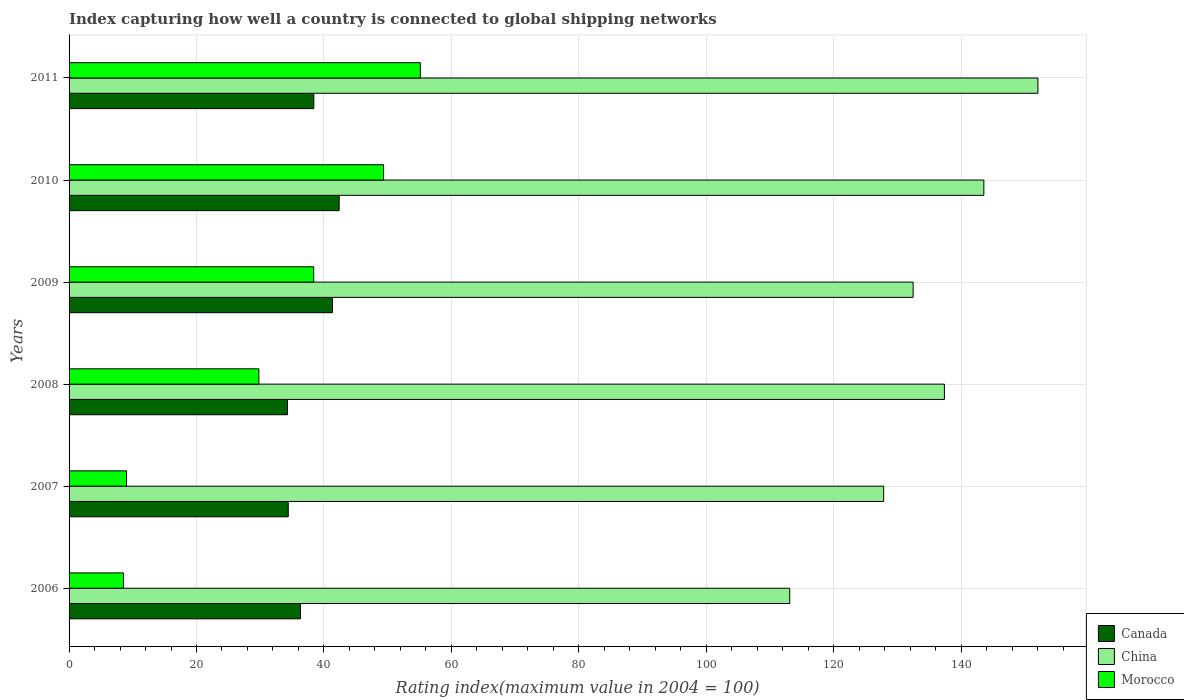How many different coloured bars are there?
Keep it short and to the point. 3. How many groups of bars are there?
Your answer should be compact. 6. Are the number of bars per tick equal to the number of legend labels?
Offer a terse response. Yes. Are the number of bars on each tick of the Y-axis equal?
Provide a short and direct response. Yes. In how many cases, is the number of bars for a given year not equal to the number of legend labels?
Offer a very short reply. 0. What is the rating index in Canada in 2007?
Keep it short and to the point. 34.4. Across all years, what is the maximum rating index in China?
Offer a very short reply. 152.06. Across all years, what is the minimum rating index in Canada?
Provide a short and direct response. 34.28. In which year was the rating index in Morocco maximum?
Make the answer very short. 2011. What is the total rating index in China in the graph?
Make the answer very short. 806.43. What is the difference between the rating index in Canada in 2008 and that in 2011?
Offer a terse response. -4.13. What is the difference between the rating index in Canada in 2010 and the rating index in China in 2008?
Provide a succinct answer. -94.99. What is the average rating index in Canada per year?
Keep it short and to the point. 37.86. In the year 2010, what is the difference between the rating index in Morocco and rating index in Canada?
Your answer should be very brief. 6.97. What is the ratio of the rating index in Canada in 2008 to that in 2010?
Offer a terse response. 0.81. Is the rating index in China in 2006 less than that in 2010?
Offer a terse response. Yes. Is the difference between the rating index in Morocco in 2006 and 2008 greater than the difference between the rating index in Canada in 2006 and 2008?
Keep it short and to the point. No. What is the difference between the highest and the second highest rating index in China?
Keep it short and to the point. 8.49. What is the difference between the highest and the lowest rating index in Canada?
Your answer should be compact. 8.11. What does the 3rd bar from the bottom in 2006 represents?
Keep it short and to the point. Morocco. Is it the case that in every year, the sum of the rating index in Morocco and rating index in Canada is greater than the rating index in China?
Give a very brief answer. No. How many bars are there?
Ensure brevity in your answer.  18. Are all the bars in the graph horizontal?
Keep it short and to the point. Yes. What is the difference between two consecutive major ticks on the X-axis?
Make the answer very short. 20. Does the graph contain grids?
Your answer should be compact. Yes. How are the legend labels stacked?
Provide a short and direct response. Vertical. What is the title of the graph?
Give a very brief answer. Index capturing how well a country is connected to global shipping networks. Does "United States" appear as one of the legend labels in the graph?
Ensure brevity in your answer.  No. What is the label or title of the X-axis?
Ensure brevity in your answer.  Rating index(maximum value in 2004 = 100). What is the label or title of the Y-axis?
Make the answer very short. Years. What is the Rating index(maximum value in 2004 = 100) of Canada in 2006?
Offer a very short reply. 36.32. What is the Rating index(maximum value in 2004 = 100) in China in 2006?
Offer a terse response. 113.1. What is the Rating index(maximum value in 2004 = 100) in Morocco in 2006?
Keep it short and to the point. 8.54. What is the Rating index(maximum value in 2004 = 100) of Canada in 2007?
Keep it short and to the point. 34.4. What is the Rating index(maximum value in 2004 = 100) of China in 2007?
Offer a terse response. 127.85. What is the Rating index(maximum value in 2004 = 100) in Morocco in 2007?
Offer a terse response. 9.02. What is the Rating index(maximum value in 2004 = 100) in Canada in 2008?
Your answer should be very brief. 34.28. What is the Rating index(maximum value in 2004 = 100) in China in 2008?
Provide a succinct answer. 137.38. What is the Rating index(maximum value in 2004 = 100) of Morocco in 2008?
Make the answer very short. 29.79. What is the Rating index(maximum value in 2004 = 100) in Canada in 2009?
Offer a terse response. 41.34. What is the Rating index(maximum value in 2004 = 100) of China in 2009?
Make the answer very short. 132.47. What is the Rating index(maximum value in 2004 = 100) in Morocco in 2009?
Offer a very short reply. 38.4. What is the Rating index(maximum value in 2004 = 100) in Canada in 2010?
Provide a succinct answer. 42.39. What is the Rating index(maximum value in 2004 = 100) of China in 2010?
Provide a succinct answer. 143.57. What is the Rating index(maximum value in 2004 = 100) in Morocco in 2010?
Your answer should be very brief. 49.36. What is the Rating index(maximum value in 2004 = 100) of Canada in 2011?
Your answer should be very brief. 38.41. What is the Rating index(maximum value in 2004 = 100) of China in 2011?
Ensure brevity in your answer.  152.06. What is the Rating index(maximum value in 2004 = 100) in Morocco in 2011?
Provide a short and direct response. 55.13. Across all years, what is the maximum Rating index(maximum value in 2004 = 100) in Canada?
Make the answer very short. 42.39. Across all years, what is the maximum Rating index(maximum value in 2004 = 100) in China?
Keep it short and to the point. 152.06. Across all years, what is the maximum Rating index(maximum value in 2004 = 100) in Morocco?
Provide a short and direct response. 55.13. Across all years, what is the minimum Rating index(maximum value in 2004 = 100) in Canada?
Your answer should be very brief. 34.28. Across all years, what is the minimum Rating index(maximum value in 2004 = 100) in China?
Offer a very short reply. 113.1. Across all years, what is the minimum Rating index(maximum value in 2004 = 100) in Morocco?
Provide a succinct answer. 8.54. What is the total Rating index(maximum value in 2004 = 100) of Canada in the graph?
Your response must be concise. 227.14. What is the total Rating index(maximum value in 2004 = 100) of China in the graph?
Make the answer very short. 806.43. What is the total Rating index(maximum value in 2004 = 100) of Morocco in the graph?
Ensure brevity in your answer.  190.24. What is the difference between the Rating index(maximum value in 2004 = 100) in Canada in 2006 and that in 2007?
Your answer should be very brief. 1.92. What is the difference between the Rating index(maximum value in 2004 = 100) in China in 2006 and that in 2007?
Keep it short and to the point. -14.75. What is the difference between the Rating index(maximum value in 2004 = 100) in Morocco in 2006 and that in 2007?
Your answer should be compact. -0.48. What is the difference between the Rating index(maximum value in 2004 = 100) in Canada in 2006 and that in 2008?
Keep it short and to the point. 2.04. What is the difference between the Rating index(maximum value in 2004 = 100) in China in 2006 and that in 2008?
Provide a succinct answer. -24.28. What is the difference between the Rating index(maximum value in 2004 = 100) of Morocco in 2006 and that in 2008?
Provide a short and direct response. -21.25. What is the difference between the Rating index(maximum value in 2004 = 100) of Canada in 2006 and that in 2009?
Keep it short and to the point. -5.02. What is the difference between the Rating index(maximum value in 2004 = 100) in China in 2006 and that in 2009?
Give a very brief answer. -19.37. What is the difference between the Rating index(maximum value in 2004 = 100) of Morocco in 2006 and that in 2009?
Your answer should be very brief. -29.86. What is the difference between the Rating index(maximum value in 2004 = 100) in Canada in 2006 and that in 2010?
Offer a very short reply. -6.07. What is the difference between the Rating index(maximum value in 2004 = 100) of China in 2006 and that in 2010?
Your response must be concise. -30.47. What is the difference between the Rating index(maximum value in 2004 = 100) in Morocco in 2006 and that in 2010?
Provide a succinct answer. -40.82. What is the difference between the Rating index(maximum value in 2004 = 100) in Canada in 2006 and that in 2011?
Provide a succinct answer. -2.09. What is the difference between the Rating index(maximum value in 2004 = 100) in China in 2006 and that in 2011?
Make the answer very short. -38.96. What is the difference between the Rating index(maximum value in 2004 = 100) in Morocco in 2006 and that in 2011?
Keep it short and to the point. -46.59. What is the difference between the Rating index(maximum value in 2004 = 100) of Canada in 2007 and that in 2008?
Offer a terse response. 0.12. What is the difference between the Rating index(maximum value in 2004 = 100) of China in 2007 and that in 2008?
Offer a terse response. -9.53. What is the difference between the Rating index(maximum value in 2004 = 100) in Morocco in 2007 and that in 2008?
Keep it short and to the point. -20.77. What is the difference between the Rating index(maximum value in 2004 = 100) of Canada in 2007 and that in 2009?
Provide a short and direct response. -6.94. What is the difference between the Rating index(maximum value in 2004 = 100) of China in 2007 and that in 2009?
Provide a short and direct response. -4.62. What is the difference between the Rating index(maximum value in 2004 = 100) in Morocco in 2007 and that in 2009?
Ensure brevity in your answer.  -29.38. What is the difference between the Rating index(maximum value in 2004 = 100) in Canada in 2007 and that in 2010?
Provide a short and direct response. -7.99. What is the difference between the Rating index(maximum value in 2004 = 100) of China in 2007 and that in 2010?
Keep it short and to the point. -15.72. What is the difference between the Rating index(maximum value in 2004 = 100) of Morocco in 2007 and that in 2010?
Give a very brief answer. -40.34. What is the difference between the Rating index(maximum value in 2004 = 100) of Canada in 2007 and that in 2011?
Offer a terse response. -4.01. What is the difference between the Rating index(maximum value in 2004 = 100) of China in 2007 and that in 2011?
Give a very brief answer. -24.21. What is the difference between the Rating index(maximum value in 2004 = 100) of Morocco in 2007 and that in 2011?
Offer a terse response. -46.11. What is the difference between the Rating index(maximum value in 2004 = 100) of Canada in 2008 and that in 2009?
Keep it short and to the point. -7.06. What is the difference between the Rating index(maximum value in 2004 = 100) of China in 2008 and that in 2009?
Offer a very short reply. 4.91. What is the difference between the Rating index(maximum value in 2004 = 100) of Morocco in 2008 and that in 2009?
Make the answer very short. -8.61. What is the difference between the Rating index(maximum value in 2004 = 100) of Canada in 2008 and that in 2010?
Provide a succinct answer. -8.11. What is the difference between the Rating index(maximum value in 2004 = 100) in China in 2008 and that in 2010?
Keep it short and to the point. -6.19. What is the difference between the Rating index(maximum value in 2004 = 100) of Morocco in 2008 and that in 2010?
Provide a short and direct response. -19.57. What is the difference between the Rating index(maximum value in 2004 = 100) in Canada in 2008 and that in 2011?
Provide a short and direct response. -4.13. What is the difference between the Rating index(maximum value in 2004 = 100) in China in 2008 and that in 2011?
Offer a terse response. -14.68. What is the difference between the Rating index(maximum value in 2004 = 100) in Morocco in 2008 and that in 2011?
Provide a succinct answer. -25.34. What is the difference between the Rating index(maximum value in 2004 = 100) of Canada in 2009 and that in 2010?
Keep it short and to the point. -1.05. What is the difference between the Rating index(maximum value in 2004 = 100) in Morocco in 2009 and that in 2010?
Provide a short and direct response. -10.96. What is the difference between the Rating index(maximum value in 2004 = 100) of Canada in 2009 and that in 2011?
Provide a short and direct response. 2.93. What is the difference between the Rating index(maximum value in 2004 = 100) of China in 2009 and that in 2011?
Your answer should be compact. -19.59. What is the difference between the Rating index(maximum value in 2004 = 100) of Morocco in 2009 and that in 2011?
Offer a terse response. -16.73. What is the difference between the Rating index(maximum value in 2004 = 100) of Canada in 2010 and that in 2011?
Keep it short and to the point. 3.98. What is the difference between the Rating index(maximum value in 2004 = 100) of China in 2010 and that in 2011?
Offer a very short reply. -8.49. What is the difference between the Rating index(maximum value in 2004 = 100) in Morocco in 2010 and that in 2011?
Provide a short and direct response. -5.77. What is the difference between the Rating index(maximum value in 2004 = 100) in Canada in 2006 and the Rating index(maximum value in 2004 = 100) in China in 2007?
Keep it short and to the point. -91.53. What is the difference between the Rating index(maximum value in 2004 = 100) in Canada in 2006 and the Rating index(maximum value in 2004 = 100) in Morocco in 2007?
Offer a very short reply. 27.3. What is the difference between the Rating index(maximum value in 2004 = 100) in China in 2006 and the Rating index(maximum value in 2004 = 100) in Morocco in 2007?
Make the answer very short. 104.08. What is the difference between the Rating index(maximum value in 2004 = 100) of Canada in 2006 and the Rating index(maximum value in 2004 = 100) of China in 2008?
Ensure brevity in your answer.  -101.06. What is the difference between the Rating index(maximum value in 2004 = 100) of Canada in 2006 and the Rating index(maximum value in 2004 = 100) of Morocco in 2008?
Keep it short and to the point. 6.53. What is the difference between the Rating index(maximum value in 2004 = 100) in China in 2006 and the Rating index(maximum value in 2004 = 100) in Morocco in 2008?
Make the answer very short. 83.31. What is the difference between the Rating index(maximum value in 2004 = 100) of Canada in 2006 and the Rating index(maximum value in 2004 = 100) of China in 2009?
Make the answer very short. -96.15. What is the difference between the Rating index(maximum value in 2004 = 100) in Canada in 2006 and the Rating index(maximum value in 2004 = 100) in Morocco in 2009?
Provide a short and direct response. -2.08. What is the difference between the Rating index(maximum value in 2004 = 100) in China in 2006 and the Rating index(maximum value in 2004 = 100) in Morocco in 2009?
Ensure brevity in your answer.  74.7. What is the difference between the Rating index(maximum value in 2004 = 100) of Canada in 2006 and the Rating index(maximum value in 2004 = 100) of China in 2010?
Make the answer very short. -107.25. What is the difference between the Rating index(maximum value in 2004 = 100) of Canada in 2006 and the Rating index(maximum value in 2004 = 100) of Morocco in 2010?
Provide a succinct answer. -13.04. What is the difference between the Rating index(maximum value in 2004 = 100) of China in 2006 and the Rating index(maximum value in 2004 = 100) of Morocco in 2010?
Provide a succinct answer. 63.74. What is the difference between the Rating index(maximum value in 2004 = 100) in Canada in 2006 and the Rating index(maximum value in 2004 = 100) in China in 2011?
Provide a succinct answer. -115.74. What is the difference between the Rating index(maximum value in 2004 = 100) of Canada in 2006 and the Rating index(maximum value in 2004 = 100) of Morocco in 2011?
Offer a terse response. -18.81. What is the difference between the Rating index(maximum value in 2004 = 100) of China in 2006 and the Rating index(maximum value in 2004 = 100) of Morocco in 2011?
Offer a terse response. 57.97. What is the difference between the Rating index(maximum value in 2004 = 100) of Canada in 2007 and the Rating index(maximum value in 2004 = 100) of China in 2008?
Ensure brevity in your answer.  -102.98. What is the difference between the Rating index(maximum value in 2004 = 100) of Canada in 2007 and the Rating index(maximum value in 2004 = 100) of Morocco in 2008?
Ensure brevity in your answer.  4.61. What is the difference between the Rating index(maximum value in 2004 = 100) in China in 2007 and the Rating index(maximum value in 2004 = 100) in Morocco in 2008?
Your response must be concise. 98.06. What is the difference between the Rating index(maximum value in 2004 = 100) in Canada in 2007 and the Rating index(maximum value in 2004 = 100) in China in 2009?
Your answer should be compact. -98.07. What is the difference between the Rating index(maximum value in 2004 = 100) in China in 2007 and the Rating index(maximum value in 2004 = 100) in Morocco in 2009?
Offer a terse response. 89.45. What is the difference between the Rating index(maximum value in 2004 = 100) in Canada in 2007 and the Rating index(maximum value in 2004 = 100) in China in 2010?
Your answer should be very brief. -109.17. What is the difference between the Rating index(maximum value in 2004 = 100) in Canada in 2007 and the Rating index(maximum value in 2004 = 100) in Morocco in 2010?
Provide a succinct answer. -14.96. What is the difference between the Rating index(maximum value in 2004 = 100) in China in 2007 and the Rating index(maximum value in 2004 = 100) in Morocco in 2010?
Provide a succinct answer. 78.49. What is the difference between the Rating index(maximum value in 2004 = 100) in Canada in 2007 and the Rating index(maximum value in 2004 = 100) in China in 2011?
Offer a terse response. -117.66. What is the difference between the Rating index(maximum value in 2004 = 100) in Canada in 2007 and the Rating index(maximum value in 2004 = 100) in Morocco in 2011?
Keep it short and to the point. -20.73. What is the difference between the Rating index(maximum value in 2004 = 100) in China in 2007 and the Rating index(maximum value in 2004 = 100) in Morocco in 2011?
Keep it short and to the point. 72.72. What is the difference between the Rating index(maximum value in 2004 = 100) of Canada in 2008 and the Rating index(maximum value in 2004 = 100) of China in 2009?
Your answer should be compact. -98.19. What is the difference between the Rating index(maximum value in 2004 = 100) of Canada in 2008 and the Rating index(maximum value in 2004 = 100) of Morocco in 2009?
Your answer should be compact. -4.12. What is the difference between the Rating index(maximum value in 2004 = 100) in China in 2008 and the Rating index(maximum value in 2004 = 100) in Morocco in 2009?
Your response must be concise. 98.98. What is the difference between the Rating index(maximum value in 2004 = 100) of Canada in 2008 and the Rating index(maximum value in 2004 = 100) of China in 2010?
Give a very brief answer. -109.29. What is the difference between the Rating index(maximum value in 2004 = 100) of Canada in 2008 and the Rating index(maximum value in 2004 = 100) of Morocco in 2010?
Give a very brief answer. -15.08. What is the difference between the Rating index(maximum value in 2004 = 100) in China in 2008 and the Rating index(maximum value in 2004 = 100) in Morocco in 2010?
Keep it short and to the point. 88.02. What is the difference between the Rating index(maximum value in 2004 = 100) in Canada in 2008 and the Rating index(maximum value in 2004 = 100) in China in 2011?
Your answer should be compact. -117.78. What is the difference between the Rating index(maximum value in 2004 = 100) of Canada in 2008 and the Rating index(maximum value in 2004 = 100) of Morocco in 2011?
Ensure brevity in your answer.  -20.85. What is the difference between the Rating index(maximum value in 2004 = 100) of China in 2008 and the Rating index(maximum value in 2004 = 100) of Morocco in 2011?
Ensure brevity in your answer.  82.25. What is the difference between the Rating index(maximum value in 2004 = 100) of Canada in 2009 and the Rating index(maximum value in 2004 = 100) of China in 2010?
Provide a short and direct response. -102.23. What is the difference between the Rating index(maximum value in 2004 = 100) in Canada in 2009 and the Rating index(maximum value in 2004 = 100) in Morocco in 2010?
Your answer should be compact. -8.02. What is the difference between the Rating index(maximum value in 2004 = 100) in China in 2009 and the Rating index(maximum value in 2004 = 100) in Morocco in 2010?
Your response must be concise. 83.11. What is the difference between the Rating index(maximum value in 2004 = 100) of Canada in 2009 and the Rating index(maximum value in 2004 = 100) of China in 2011?
Offer a terse response. -110.72. What is the difference between the Rating index(maximum value in 2004 = 100) in Canada in 2009 and the Rating index(maximum value in 2004 = 100) in Morocco in 2011?
Your response must be concise. -13.79. What is the difference between the Rating index(maximum value in 2004 = 100) in China in 2009 and the Rating index(maximum value in 2004 = 100) in Morocco in 2011?
Provide a short and direct response. 77.34. What is the difference between the Rating index(maximum value in 2004 = 100) in Canada in 2010 and the Rating index(maximum value in 2004 = 100) in China in 2011?
Keep it short and to the point. -109.67. What is the difference between the Rating index(maximum value in 2004 = 100) in Canada in 2010 and the Rating index(maximum value in 2004 = 100) in Morocco in 2011?
Offer a very short reply. -12.74. What is the difference between the Rating index(maximum value in 2004 = 100) in China in 2010 and the Rating index(maximum value in 2004 = 100) in Morocco in 2011?
Make the answer very short. 88.44. What is the average Rating index(maximum value in 2004 = 100) in Canada per year?
Your answer should be compact. 37.86. What is the average Rating index(maximum value in 2004 = 100) of China per year?
Your answer should be very brief. 134.41. What is the average Rating index(maximum value in 2004 = 100) of Morocco per year?
Your response must be concise. 31.71. In the year 2006, what is the difference between the Rating index(maximum value in 2004 = 100) in Canada and Rating index(maximum value in 2004 = 100) in China?
Offer a very short reply. -76.78. In the year 2006, what is the difference between the Rating index(maximum value in 2004 = 100) in Canada and Rating index(maximum value in 2004 = 100) in Morocco?
Make the answer very short. 27.78. In the year 2006, what is the difference between the Rating index(maximum value in 2004 = 100) of China and Rating index(maximum value in 2004 = 100) of Morocco?
Provide a short and direct response. 104.56. In the year 2007, what is the difference between the Rating index(maximum value in 2004 = 100) of Canada and Rating index(maximum value in 2004 = 100) of China?
Provide a succinct answer. -93.45. In the year 2007, what is the difference between the Rating index(maximum value in 2004 = 100) of Canada and Rating index(maximum value in 2004 = 100) of Morocco?
Keep it short and to the point. 25.38. In the year 2007, what is the difference between the Rating index(maximum value in 2004 = 100) of China and Rating index(maximum value in 2004 = 100) of Morocco?
Provide a succinct answer. 118.83. In the year 2008, what is the difference between the Rating index(maximum value in 2004 = 100) of Canada and Rating index(maximum value in 2004 = 100) of China?
Your answer should be very brief. -103.1. In the year 2008, what is the difference between the Rating index(maximum value in 2004 = 100) of Canada and Rating index(maximum value in 2004 = 100) of Morocco?
Provide a short and direct response. 4.49. In the year 2008, what is the difference between the Rating index(maximum value in 2004 = 100) in China and Rating index(maximum value in 2004 = 100) in Morocco?
Give a very brief answer. 107.59. In the year 2009, what is the difference between the Rating index(maximum value in 2004 = 100) of Canada and Rating index(maximum value in 2004 = 100) of China?
Offer a very short reply. -91.13. In the year 2009, what is the difference between the Rating index(maximum value in 2004 = 100) of Canada and Rating index(maximum value in 2004 = 100) of Morocco?
Give a very brief answer. 2.94. In the year 2009, what is the difference between the Rating index(maximum value in 2004 = 100) in China and Rating index(maximum value in 2004 = 100) in Morocco?
Offer a very short reply. 94.07. In the year 2010, what is the difference between the Rating index(maximum value in 2004 = 100) in Canada and Rating index(maximum value in 2004 = 100) in China?
Provide a short and direct response. -101.18. In the year 2010, what is the difference between the Rating index(maximum value in 2004 = 100) in Canada and Rating index(maximum value in 2004 = 100) in Morocco?
Offer a very short reply. -6.97. In the year 2010, what is the difference between the Rating index(maximum value in 2004 = 100) of China and Rating index(maximum value in 2004 = 100) of Morocco?
Provide a short and direct response. 94.21. In the year 2011, what is the difference between the Rating index(maximum value in 2004 = 100) of Canada and Rating index(maximum value in 2004 = 100) of China?
Offer a very short reply. -113.65. In the year 2011, what is the difference between the Rating index(maximum value in 2004 = 100) in Canada and Rating index(maximum value in 2004 = 100) in Morocco?
Your response must be concise. -16.72. In the year 2011, what is the difference between the Rating index(maximum value in 2004 = 100) of China and Rating index(maximum value in 2004 = 100) of Morocco?
Offer a very short reply. 96.93. What is the ratio of the Rating index(maximum value in 2004 = 100) of Canada in 2006 to that in 2007?
Give a very brief answer. 1.06. What is the ratio of the Rating index(maximum value in 2004 = 100) of China in 2006 to that in 2007?
Make the answer very short. 0.88. What is the ratio of the Rating index(maximum value in 2004 = 100) in Morocco in 2006 to that in 2007?
Make the answer very short. 0.95. What is the ratio of the Rating index(maximum value in 2004 = 100) in Canada in 2006 to that in 2008?
Ensure brevity in your answer.  1.06. What is the ratio of the Rating index(maximum value in 2004 = 100) in China in 2006 to that in 2008?
Provide a succinct answer. 0.82. What is the ratio of the Rating index(maximum value in 2004 = 100) of Morocco in 2006 to that in 2008?
Give a very brief answer. 0.29. What is the ratio of the Rating index(maximum value in 2004 = 100) in Canada in 2006 to that in 2009?
Give a very brief answer. 0.88. What is the ratio of the Rating index(maximum value in 2004 = 100) in China in 2006 to that in 2009?
Keep it short and to the point. 0.85. What is the ratio of the Rating index(maximum value in 2004 = 100) of Morocco in 2006 to that in 2009?
Offer a terse response. 0.22. What is the ratio of the Rating index(maximum value in 2004 = 100) in Canada in 2006 to that in 2010?
Your answer should be compact. 0.86. What is the ratio of the Rating index(maximum value in 2004 = 100) of China in 2006 to that in 2010?
Give a very brief answer. 0.79. What is the ratio of the Rating index(maximum value in 2004 = 100) in Morocco in 2006 to that in 2010?
Make the answer very short. 0.17. What is the ratio of the Rating index(maximum value in 2004 = 100) in Canada in 2006 to that in 2011?
Offer a very short reply. 0.95. What is the ratio of the Rating index(maximum value in 2004 = 100) of China in 2006 to that in 2011?
Your response must be concise. 0.74. What is the ratio of the Rating index(maximum value in 2004 = 100) of Morocco in 2006 to that in 2011?
Keep it short and to the point. 0.15. What is the ratio of the Rating index(maximum value in 2004 = 100) of Canada in 2007 to that in 2008?
Your response must be concise. 1. What is the ratio of the Rating index(maximum value in 2004 = 100) of China in 2007 to that in 2008?
Ensure brevity in your answer.  0.93. What is the ratio of the Rating index(maximum value in 2004 = 100) of Morocco in 2007 to that in 2008?
Provide a short and direct response. 0.3. What is the ratio of the Rating index(maximum value in 2004 = 100) in Canada in 2007 to that in 2009?
Ensure brevity in your answer.  0.83. What is the ratio of the Rating index(maximum value in 2004 = 100) of China in 2007 to that in 2009?
Make the answer very short. 0.97. What is the ratio of the Rating index(maximum value in 2004 = 100) in Morocco in 2007 to that in 2009?
Make the answer very short. 0.23. What is the ratio of the Rating index(maximum value in 2004 = 100) in Canada in 2007 to that in 2010?
Provide a succinct answer. 0.81. What is the ratio of the Rating index(maximum value in 2004 = 100) of China in 2007 to that in 2010?
Provide a short and direct response. 0.89. What is the ratio of the Rating index(maximum value in 2004 = 100) in Morocco in 2007 to that in 2010?
Your answer should be compact. 0.18. What is the ratio of the Rating index(maximum value in 2004 = 100) in Canada in 2007 to that in 2011?
Provide a succinct answer. 0.9. What is the ratio of the Rating index(maximum value in 2004 = 100) of China in 2007 to that in 2011?
Offer a very short reply. 0.84. What is the ratio of the Rating index(maximum value in 2004 = 100) of Morocco in 2007 to that in 2011?
Provide a short and direct response. 0.16. What is the ratio of the Rating index(maximum value in 2004 = 100) in Canada in 2008 to that in 2009?
Give a very brief answer. 0.83. What is the ratio of the Rating index(maximum value in 2004 = 100) of China in 2008 to that in 2009?
Ensure brevity in your answer.  1.04. What is the ratio of the Rating index(maximum value in 2004 = 100) in Morocco in 2008 to that in 2009?
Give a very brief answer. 0.78. What is the ratio of the Rating index(maximum value in 2004 = 100) of Canada in 2008 to that in 2010?
Your answer should be very brief. 0.81. What is the ratio of the Rating index(maximum value in 2004 = 100) of China in 2008 to that in 2010?
Provide a succinct answer. 0.96. What is the ratio of the Rating index(maximum value in 2004 = 100) in Morocco in 2008 to that in 2010?
Your response must be concise. 0.6. What is the ratio of the Rating index(maximum value in 2004 = 100) in Canada in 2008 to that in 2011?
Offer a terse response. 0.89. What is the ratio of the Rating index(maximum value in 2004 = 100) of China in 2008 to that in 2011?
Offer a terse response. 0.9. What is the ratio of the Rating index(maximum value in 2004 = 100) in Morocco in 2008 to that in 2011?
Your response must be concise. 0.54. What is the ratio of the Rating index(maximum value in 2004 = 100) of Canada in 2009 to that in 2010?
Give a very brief answer. 0.98. What is the ratio of the Rating index(maximum value in 2004 = 100) in China in 2009 to that in 2010?
Give a very brief answer. 0.92. What is the ratio of the Rating index(maximum value in 2004 = 100) of Morocco in 2009 to that in 2010?
Provide a succinct answer. 0.78. What is the ratio of the Rating index(maximum value in 2004 = 100) of Canada in 2009 to that in 2011?
Offer a terse response. 1.08. What is the ratio of the Rating index(maximum value in 2004 = 100) in China in 2009 to that in 2011?
Give a very brief answer. 0.87. What is the ratio of the Rating index(maximum value in 2004 = 100) of Morocco in 2009 to that in 2011?
Make the answer very short. 0.7. What is the ratio of the Rating index(maximum value in 2004 = 100) in Canada in 2010 to that in 2011?
Offer a terse response. 1.1. What is the ratio of the Rating index(maximum value in 2004 = 100) of China in 2010 to that in 2011?
Give a very brief answer. 0.94. What is the ratio of the Rating index(maximum value in 2004 = 100) in Morocco in 2010 to that in 2011?
Offer a terse response. 0.9. What is the difference between the highest and the second highest Rating index(maximum value in 2004 = 100) of Canada?
Provide a succinct answer. 1.05. What is the difference between the highest and the second highest Rating index(maximum value in 2004 = 100) in China?
Provide a short and direct response. 8.49. What is the difference between the highest and the second highest Rating index(maximum value in 2004 = 100) of Morocco?
Your answer should be compact. 5.77. What is the difference between the highest and the lowest Rating index(maximum value in 2004 = 100) of Canada?
Keep it short and to the point. 8.11. What is the difference between the highest and the lowest Rating index(maximum value in 2004 = 100) of China?
Your answer should be compact. 38.96. What is the difference between the highest and the lowest Rating index(maximum value in 2004 = 100) in Morocco?
Ensure brevity in your answer.  46.59. 